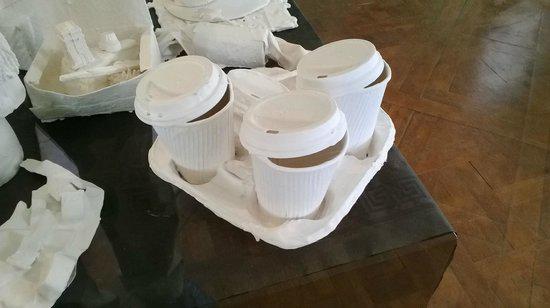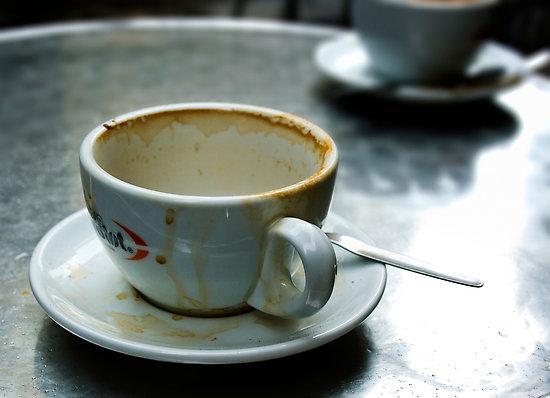The first image is the image on the left, the second image is the image on the right. Assess this claim about the two images: "A single dirty coffee cup sits on a table.". Correct or not? Answer yes or no. Yes. The first image is the image on the left, the second image is the image on the right. For the images displayed, is the sentence "In at least one image there is a dirty coffee cup with a spoon set on the cup plate." factually correct? Answer yes or no. Yes. 